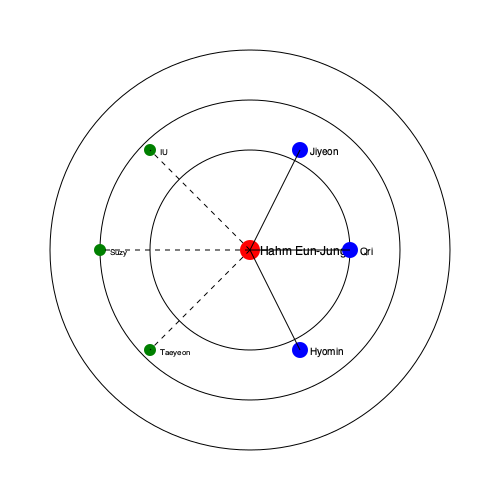Based on the social network diagram, which group of K-pop idols has the strongest direct connection to Hahm Eun-Jung, and what does this imply about her career history? To answer this question, we need to analyze the node-link diagram carefully:

1. Hahm Eun-Jung is represented by the red node at the center of the diagram.

2. There are three concentric circles, representing different levels of connection strength.

3. The blue nodes represent a group of three idols (Jiyeon, Qri, and Hyomin) who are closest to Hahm Eun-Jung in the innermost circle. These connections are represented by solid lines, indicating strong, direct relationships.

4. The green nodes represent other K-pop idols (IU, Taeyeon, and Suzy) who are placed in the outer circles. Their connections to Hahm Eun-Jung are represented by dashed lines, indicating weaker or indirect relationships.

5. The blue nodes are all equidistant from Hahm Eun-Jung and closer than any other nodes, suggesting they belong to the same group or have a similar relationship with her.

6. Given that Hahm Eun-Jung is known to be a member of the K-pop girl group T-ara, we can deduce that the blue nodes represent her fellow T-ara members.

This diagram implies that Hahm Eun-Jung's strongest connections in the K-pop industry are with her T-ara group members. This suggests that her career history is closely tied to her activities as a member of T-ara, which has been a significant part of her professional life in the K-pop industry.
Answer: T-ara members (Jiyeon, Qri, and Hyomin), implying Hahm Eun-Jung's career is closely tied to T-ara. 